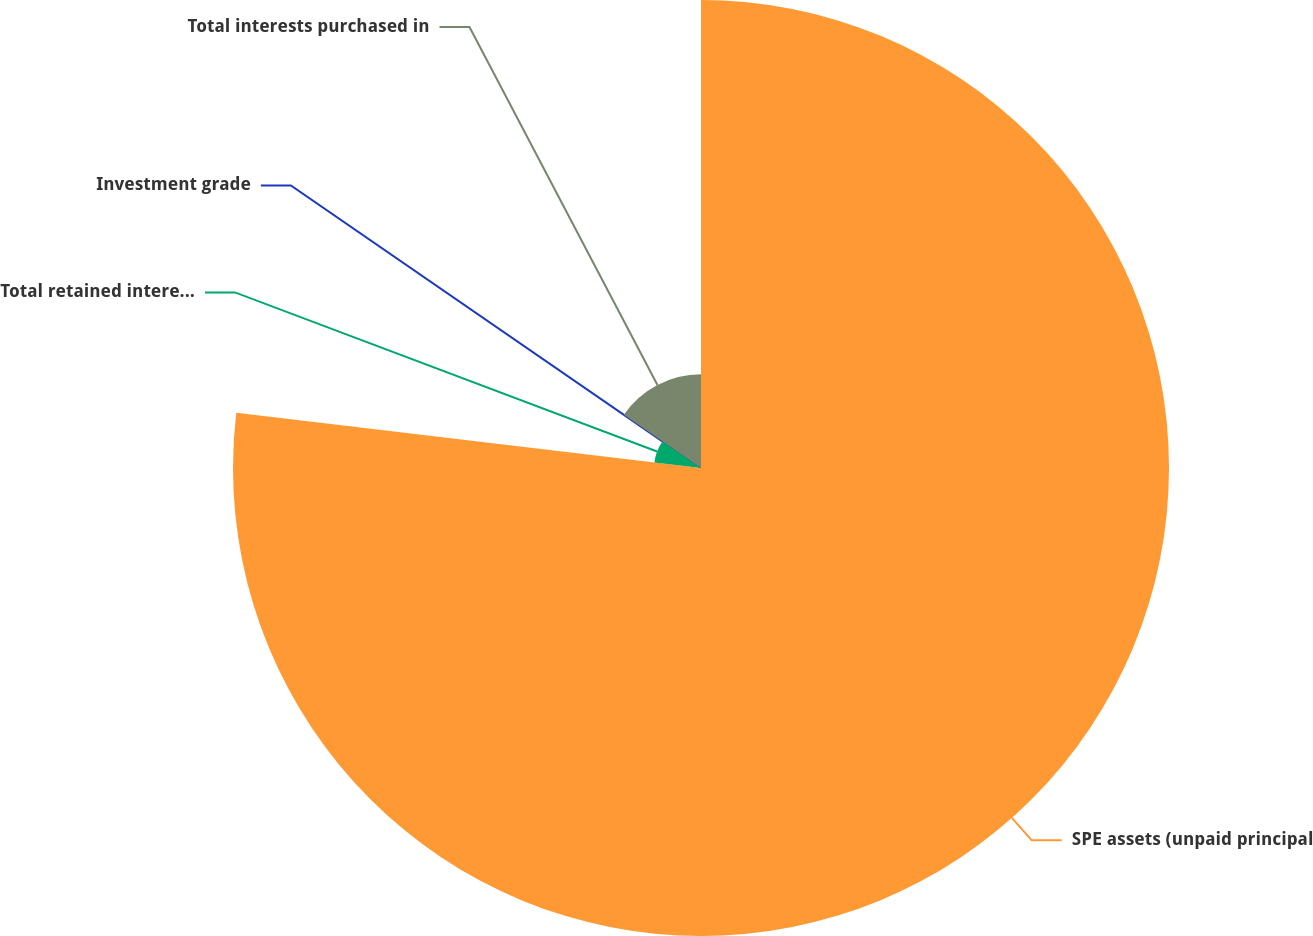Convert chart to OTSL. <chart><loc_0><loc_0><loc_500><loc_500><pie_chart><fcel>SPE assets (unpaid principal<fcel>Total retained interests (fair<fcel>Investment grade<fcel>Total interests purchased in<nl><fcel>76.88%<fcel>7.71%<fcel>0.02%<fcel>15.39%<nl></chart> 